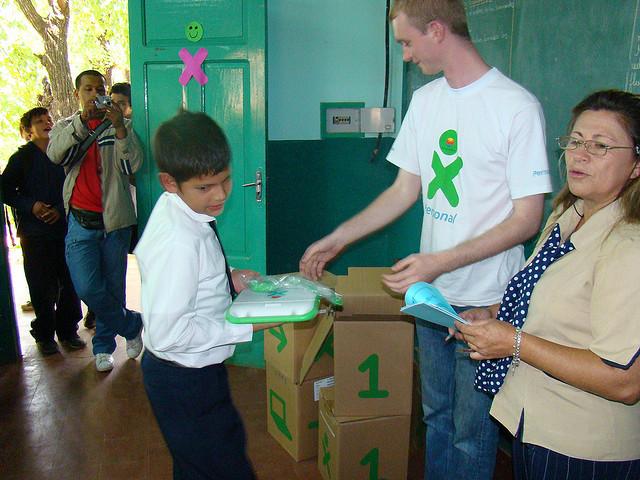Are these people nice?
Answer briefly. Yes. What is the boy receiving?
Be succinct. Food. What type of scene is this?
Short answer required. Charity. 